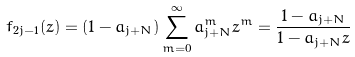Convert formula to latex. <formula><loc_0><loc_0><loc_500><loc_500>f _ { 2 j - 1 } ( z ) = ( 1 - a _ { j + N } ) \sum _ { m = 0 } ^ { \infty } a _ { j + N } ^ { m } z ^ { m } = \frac { 1 - a _ { j + N } } { 1 - a _ { j + N } z }</formula> 